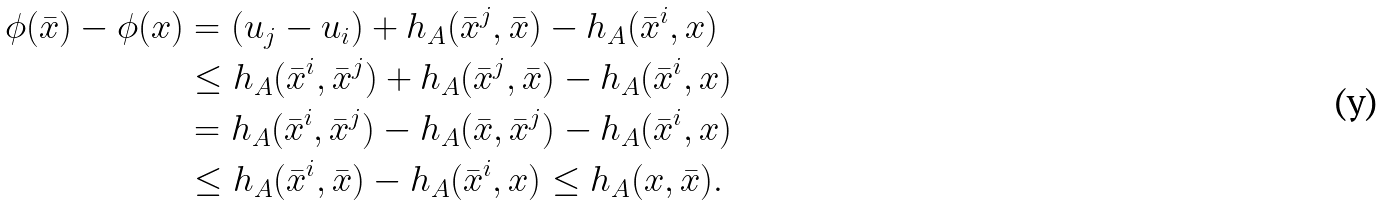Convert formula to latex. <formula><loc_0><loc_0><loc_500><loc_500>\phi ( \bar { x } ) - \phi ( x ) & = ( u _ { j } - u _ { i } ) + h _ { A } ( \bar { x } ^ { j } , \bar { x } ) - h _ { A } ( \bar { x } ^ { i } , x ) \\ & \leq h _ { A } ( \bar { x } ^ { i } , \bar { x } ^ { j } ) + h _ { A } ( \bar { x } ^ { j } , \bar { x } ) - h _ { A } ( \bar { x } ^ { i } , x ) \\ & = h _ { A } ( \bar { x } ^ { i } , \bar { x } ^ { j } ) - h _ { A } ( \bar { x } , \bar { x } ^ { j } ) - h _ { A } ( \bar { x } ^ { i } , x ) \\ & \leq h _ { A } ( \bar { x } ^ { i } , \bar { x } ) - h _ { A } ( \bar { x } ^ { i } , x ) \leq h _ { A } ( x , \bar { x } ) .</formula> 